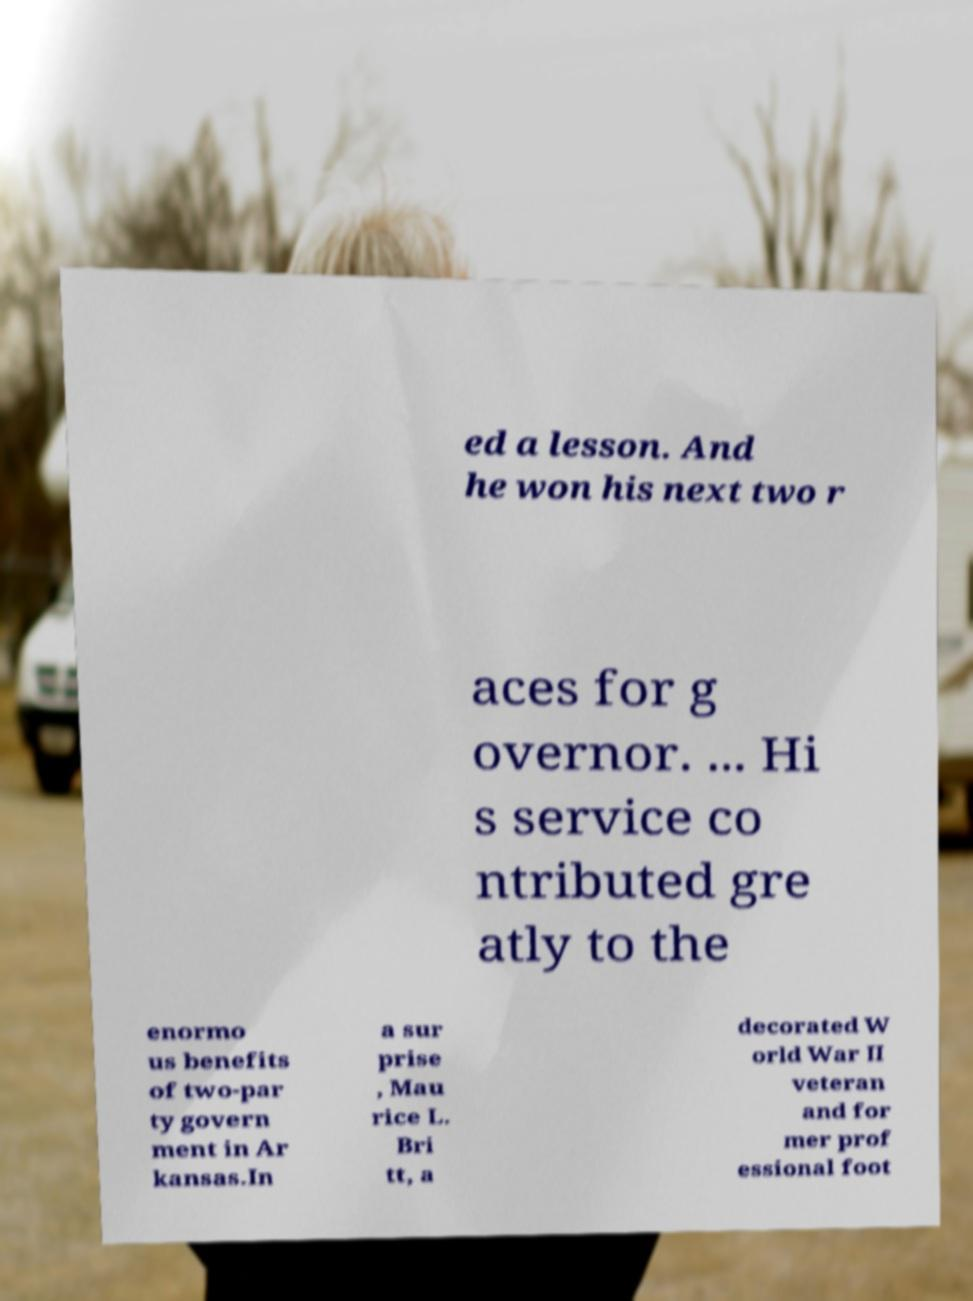Could you assist in decoding the text presented in this image and type it out clearly? ed a lesson. And he won his next two r aces for g overnor. ... Hi s service co ntributed gre atly to the enormo us benefits of two-par ty govern ment in Ar kansas.In a sur prise , Mau rice L. Bri tt, a decorated W orld War II veteran and for mer prof essional foot 